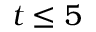Convert formula to latex. <formula><loc_0><loc_0><loc_500><loc_500>t \leq 5</formula> 